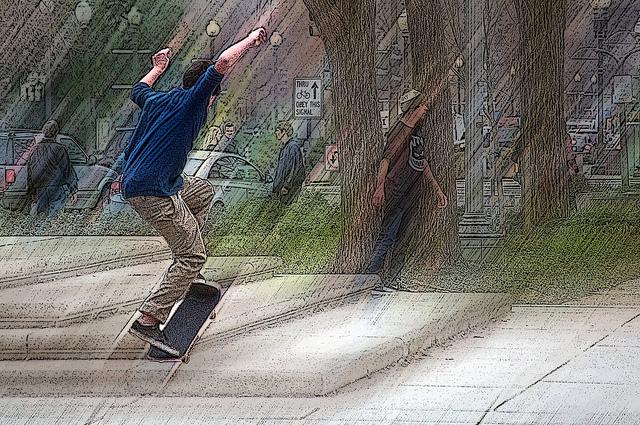Is this picture photoshopped?
Answer briefly. Yes. What is the boy riding?
Concise answer only. Skateboard. How many steps are there on the stairs?
Give a very brief answer. 4. 